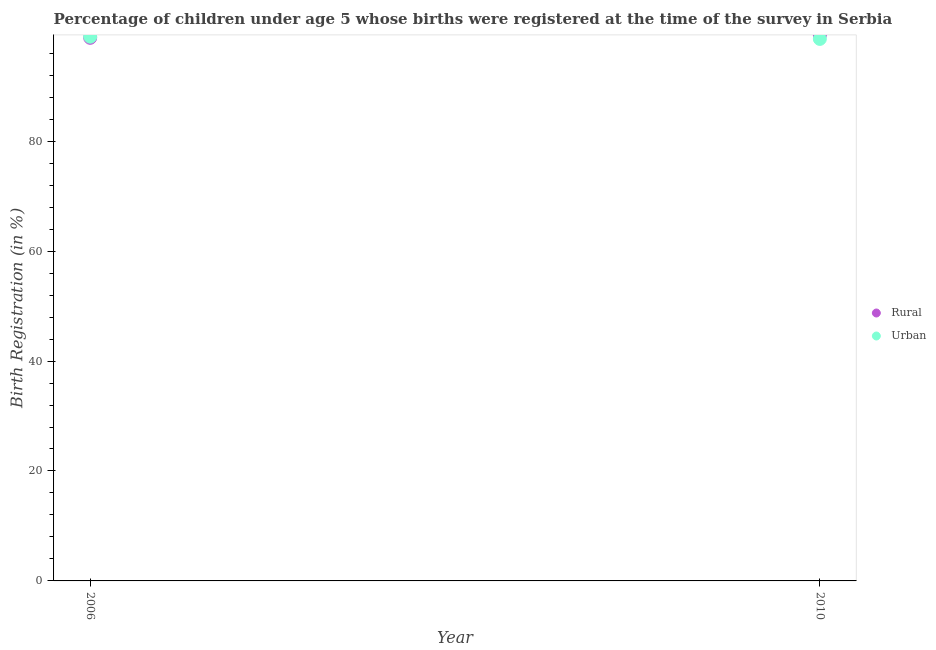How many different coloured dotlines are there?
Make the answer very short. 2. What is the urban birth registration in 2010?
Keep it short and to the point. 98.6. Across all years, what is the maximum urban birth registration?
Offer a very short reply. 99. Across all years, what is the minimum rural birth registration?
Offer a terse response. 98.8. In which year was the urban birth registration minimum?
Ensure brevity in your answer.  2010. What is the total urban birth registration in the graph?
Offer a terse response. 197.6. What is the difference between the urban birth registration in 2006 and that in 2010?
Offer a terse response. 0.4. What is the difference between the rural birth registration in 2010 and the urban birth registration in 2006?
Give a very brief answer. 0.3. What is the average rural birth registration per year?
Keep it short and to the point. 99.05. In the year 2010, what is the difference between the rural birth registration and urban birth registration?
Ensure brevity in your answer.  0.7. What is the ratio of the urban birth registration in 2006 to that in 2010?
Offer a very short reply. 1. How many legend labels are there?
Give a very brief answer. 2. How are the legend labels stacked?
Make the answer very short. Vertical. What is the title of the graph?
Your answer should be compact. Percentage of children under age 5 whose births were registered at the time of the survey in Serbia. Does "Arms imports" appear as one of the legend labels in the graph?
Provide a succinct answer. No. What is the label or title of the X-axis?
Offer a terse response. Year. What is the label or title of the Y-axis?
Give a very brief answer. Birth Registration (in %). What is the Birth Registration (in %) in Rural in 2006?
Provide a short and direct response. 98.8. What is the Birth Registration (in %) of Rural in 2010?
Ensure brevity in your answer.  99.3. What is the Birth Registration (in %) in Urban in 2010?
Ensure brevity in your answer.  98.6. Across all years, what is the maximum Birth Registration (in %) of Rural?
Your answer should be compact. 99.3. Across all years, what is the minimum Birth Registration (in %) in Rural?
Your response must be concise. 98.8. Across all years, what is the minimum Birth Registration (in %) in Urban?
Provide a short and direct response. 98.6. What is the total Birth Registration (in %) of Rural in the graph?
Provide a succinct answer. 198.1. What is the total Birth Registration (in %) of Urban in the graph?
Provide a short and direct response. 197.6. What is the average Birth Registration (in %) of Rural per year?
Provide a succinct answer. 99.05. What is the average Birth Registration (in %) of Urban per year?
Give a very brief answer. 98.8. In the year 2006, what is the difference between the Birth Registration (in %) in Rural and Birth Registration (in %) in Urban?
Your answer should be very brief. -0.2. What is the ratio of the Birth Registration (in %) in Urban in 2006 to that in 2010?
Offer a very short reply. 1. What is the difference between the highest and the lowest Birth Registration (in %) in Urban?
Offer a terse response. 0.4. 